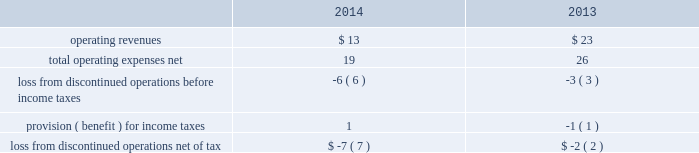During 2014 , the company closed on thirteen acquisitions of various regulated water and wastewater systems for a total aggregate purchase price of $ 9 .
Assets acquired , principally plant , totaled $ 17 .
Liabilities assumed totaled $ 8 , including $ 5 of contributions in aid of construction and assumed debt of $ 2 .
During 2013 , the company closed on fifteen acquisitions of various regulated water and wastewater systems for a total aggregate net purchase price of $ 24 .
Assets acquired , primarily utility plant , totaled $ 67 .
Liabilities assumed totaled $ 43 , including $ 26 of contributions in aid of construction and assumed debt of $ 13 .
Included in these totals was the company 2019s november 14 , 2013 acquisition of all of the capital stock of dale service corporation ( 201cdale 201d ) , a regulated wastewater utility company , for a total cash purchase price of $ 5 ( net of cash acquired of $ 7 ) , plus assumed liabilities .
The dale acquisition was accounted for as a business combination ; accordingly , operating results from november 14 , 2013 were included in the company 2019s results of operations .
The purchase price was allocated to the net tangible and intangible assets based upon their estimated fair values at the date of acquisition .
The company 2019s regulatory practice was followed whereby property , plant and equipment ( rate base ) was considered fair value for business combination purposes .
Similarly , regulatory assets and liabilities acquired were recorded at book value and are subject to regulatory approval where applicable .
The acquired debt was valued in a manner consistent with the company 2019s level 3 debt .
See note 17 2014fair value of financial instruments .
Non-cash assets acquired in the dale acquisition , primarily utility plant , totaled $ 41 ; liabilities assumed totaled $ 36 , including debt assumed of $ 13 and contributions of $ 19 .
Divestitures in november 2014 , the company completed the sale of terratec , previously included in the market-based businesses .
After post-close adjustments , net proceeds from the sale totaled $ 1 , and the company recorded a pretax loss on sale of $ 1 .
The table summarizes the operating results of discontinued operations presented in the accompanying consolidated statements of operations for the years ended december 31: .
The provision for income taxes of discontinued operations includes the recognition of tax expense related to the difference between the tax basis and book basis of assets upon the sales of terratec that resulted in taxable gains , since an election was made under section 338 ( h ) ( 10 ) of the internal revenue code to treat the sales as asset sales .
There were no assets or liabilities of discontinued operations in the accompanying consolidated balance sheets as of december 31 , 2015 and 2014. .
What was the operating income in 2014? 
Rationale: the operating income is the operating revenues less operating expenses
Computations: (13 - 19)
Answer: -6.0. 